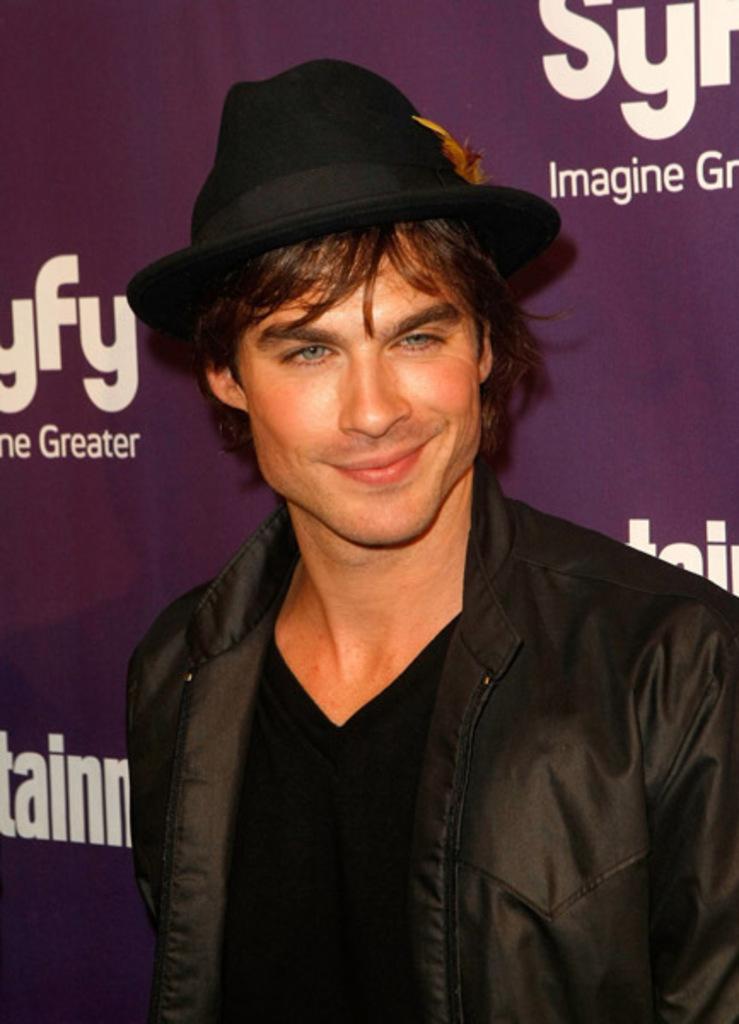Can you describe this image briefly? In the middle of the image, there is a person in black color jacket, wearing black color cap and smiling. In the background, there are white color texts on the violet color surface. 